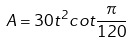<formula> <loc_0><loc_0><loc_500><loc_500>A = 3 0 t ^ { 2 } c o t \frac { \pi } { 1 2 0 }</formula> 